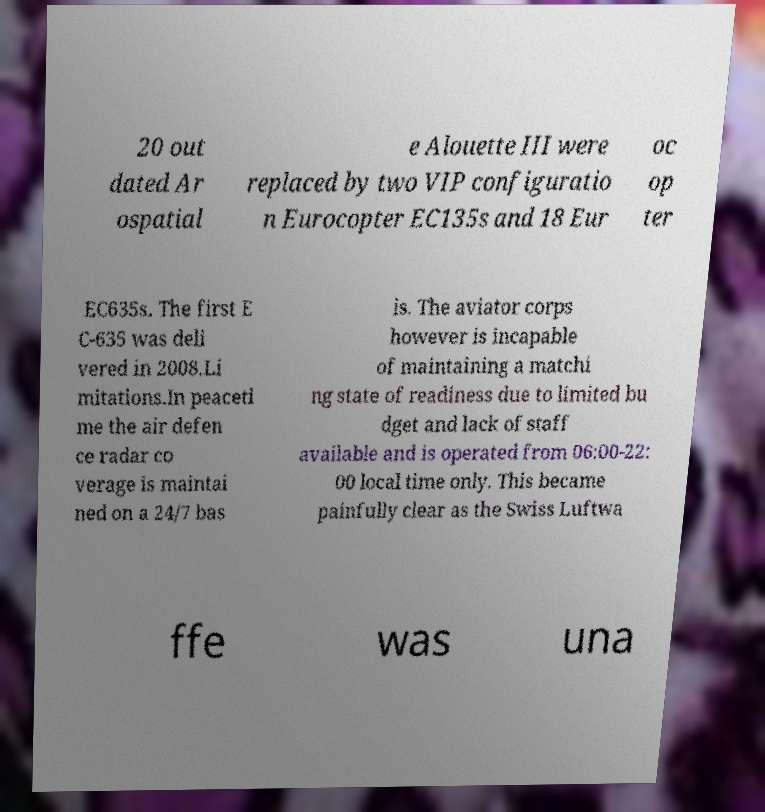Can you read and provide the text displayed in the image?This photo seems to have some interesting text. Can you extract and type it out for me? 20 out dated Ar ospatial e Alouette III were replaced by two VIP configuratio n Eurocopter EC135s and 18 Eur oc op ter EC635s. The first E C-635 was deli vered in 2008.Li mitations.In peaceti me the air defen ce radar co verage is maintai ned on a 24/7 bas is. The aviator corps however is incapable of maintaining a matchi ng state of readiness due to limited bu dget and lack of staff available and is operated from 06:00-22: 00 local time only. This became painfully clear as the Swiss Luftwa ffe was una 